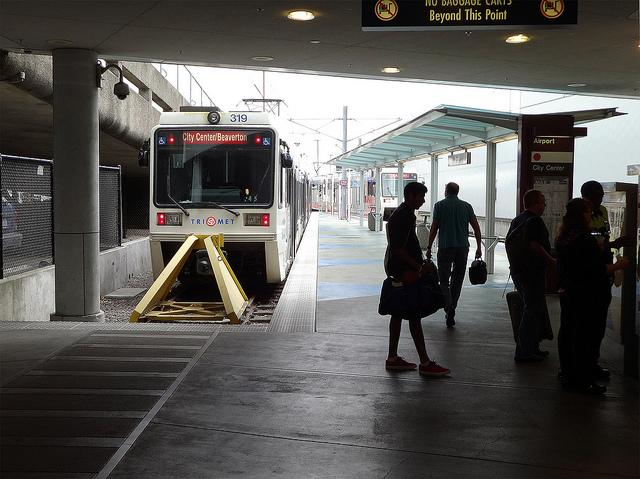The people carrying bags are doing so because of what reason? Please explain your reasoning. air travel. They are traveling. 